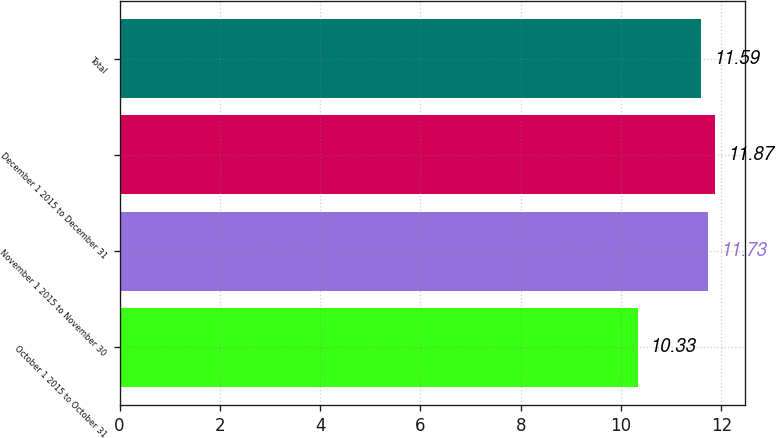Convert chart to OTSL. <chart><loc_0><loc_0><loc_500><loc_500><bar_chart><fcel>October 1 2015 to October 31<fcel>November 1 2015 to November 30<fcel>December 1 2015 to December 31<fcel>Total<nl><fcel>10.33<fcel>11.73<fcel>11.87<fcel>11.59<nl></chart> 